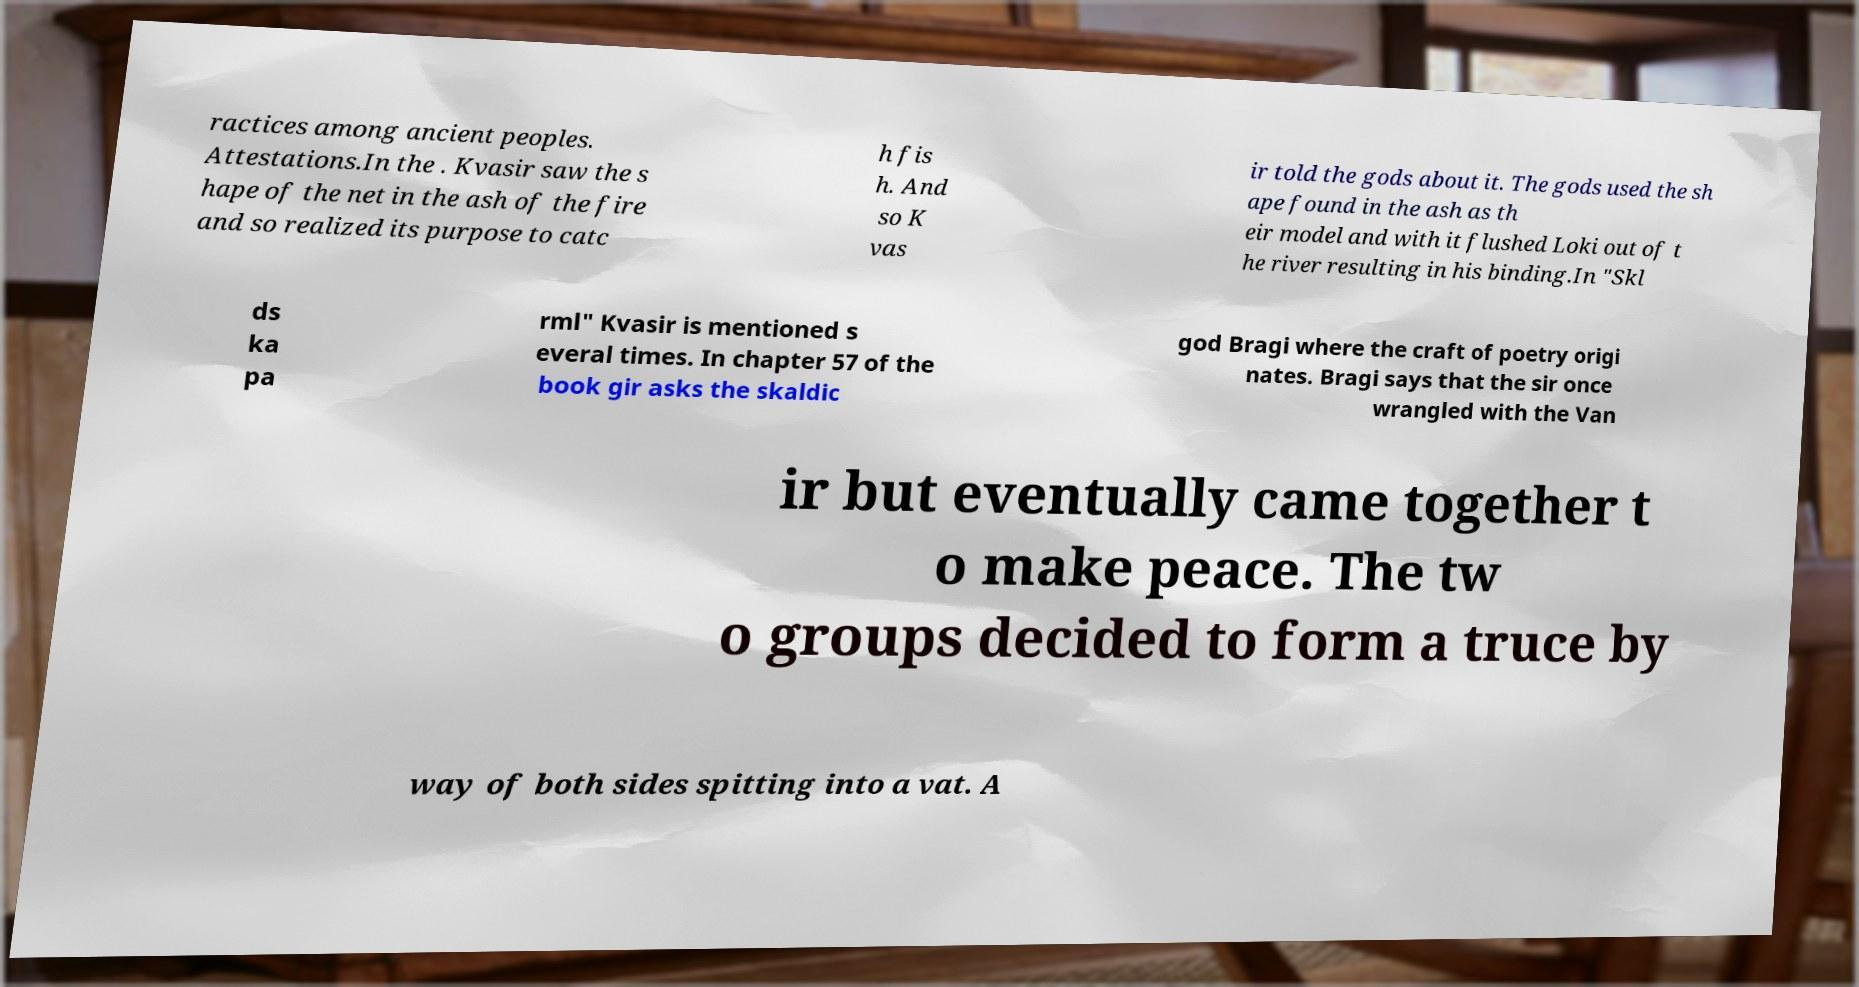What messages or text are displayed in this image? I need them in a readable, typed format. ractices among ancient peoples. Attestations.In the . Kvasir saw the s hape of the net in the ash of the fire and so realized its purpose to catc h fis h. And so K vas ir told the gods about it. The gods used the sh ape found in the ash as th eir model and with it flushed Loki out of t he river resulting in his binding.In "Skl ds ka pa rml" Kvasir is mentioned s everal times. In chapter 57 of the book gir asks the skaldic god Bragi where the craft of poetry origi nates. Bragi says that the sir once wrangled with the Van ir but eventually came together t o make peace. The tw o groups decided to form a truce by way of both sides spitting into a vat. A 